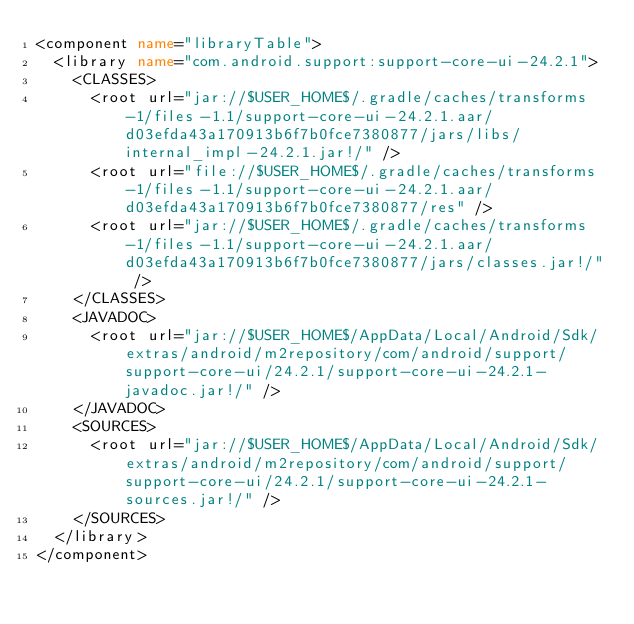<code> <loc_0><loc_0><loc_500><loc_500><_XML_><component name="libraryTable">
  <library name="com.android.support:support-core-ui-24.2.1">
    <CLASSES>
      <root url="jar://$USER_HOME$/.gradle/caches/transforms-1/files-1.1/support-core-ui-24.2.1.aar/d03efda43a170913b6f7b0fce7380877/jars/libs/internal_impl-24.2.1.jar!/" />
      <root url="file://$USER_HOME$/.gradle/caches/transforms-1/files-1.1/support-core-ui-24.2.1.aar/d03efda43a170913b6f7b0fce7380877/res" />
      <root url="jar://$USER_HOME$/.gradle/caches/transforms-1/files-1.1/support-core-ui-24.2.1.aar/d03efda43a170913b6f7b0fce7380877/jars/classes.jar!/" />
    </CLASSES>
    <JAVADOC>
      <root url="jar://$USER_HOME$/AppData/Local/Android/Sdk/extras/android/m2repository/com/android/support/support-core-ui/24.2.1/support-core-ui-24.2.1-javadoc.jar!/" />
    </JAVADOC>
    <SOURCES>
      <root url="jar://$USER_HOME$/AppData/Local/Android/Sdk/extras/android/m2repository/com/android/support/support-core-ui/24.2.1/support-core-ui-24.2.1-sources.jar!/" />
    </SOURCES>
  </library>
</component></code> 